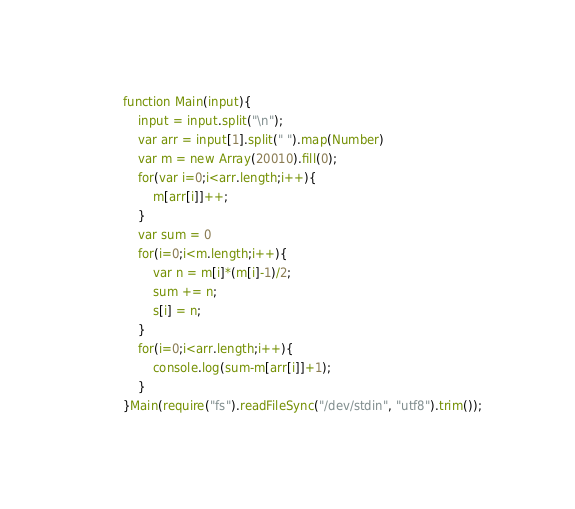Convert code to text. <code><loc_0><loc_0><loc_500><loc_500><_JavaScript_>function Main(input){
	input = input.split("\n");
	var arr = input[1].split(" ").map(Number)
	var m = new Array(20010).fill(0);
	for(var i=0;i<arr.length;i++){
		m[arr[i]]++;
	}
	var sum = 0
	for(i=0;i<m.length;i++){
		var n = m[i]*(m[i]-1)/2;
		sum += n;
		s[i] = n;
	}
	for(i=0;i<arr.length;i++){
		console.log(sum-m[arr[i]]+1);
	}
}Main(require("fs").readFileSync("/dev/stdin", "utf8").trim());
</code> 